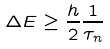<formula> <loc_0><loc_0><loc_500><loc_500>\Delta E \geq \frac { h } { 2 } \frac { 1 } { \tau _ { n } }</formula> 